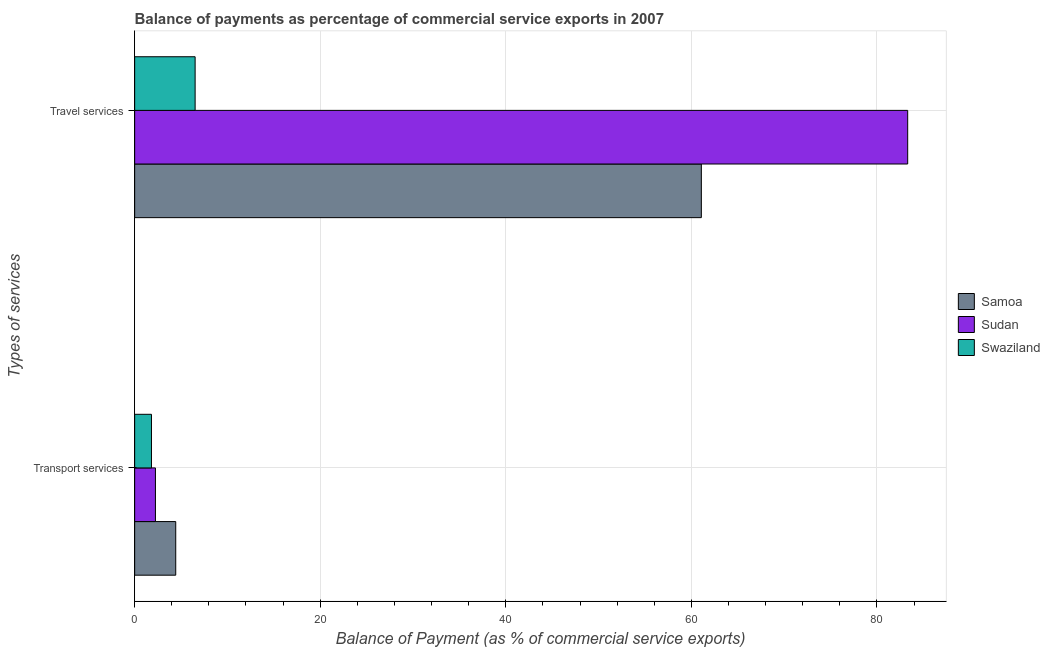How many groups of bars are there?
Your answer should be very brief. 2. Are the number of bars per tick equal to the number of legend labels?
Your answer should be compact. Yes. How many bars are there on the 2nd tick from the bottom?
Offer a very short reply. 3. What is the label of the 1st group of bars from the top?
Your response must be concise. Travel services. What is the balance of payments of transport services in Sudan?
Provide a short and direct response. 2.24. Across all countries, what is the maximum balance of payments of travel services?
Offer a terse response. 83.32. Across all countries, what is the minimum balance of payments of transport services?
Provide a succinct answer. 1.81. In which country was the balance of payments of travel services maximum?
Provide a succinct answer. Sudan. In which country was the balance of payments of travel services minimum?
Offer a very short reply. Swaziland. What is the total balance of payments of travel services in the graph?
Give a very brief answer. 150.92. What is the difference between the balance of payments of travel services in Sudan and that in Swaziland?
Your answer should be compact. 76.8. What is the difference between the balance of payments of transport services in Sudan and the balance of payments of travel services in Swaziland?
Offer a very short reply. -4.28. What is the average balance of payments of travel services per country?
Ensure brevity in your answer.  50.31. What is the difference between the balance of payments of transport services and balance of payments of travel services in Swaziland?
Ensure brevity in your answer.  -4.7. In how many countries, is the balance of payments of transport services greater than 76 %?
Offer a very short reply. 0. What is the ratio of the balance of payments of transport services in Swaziland to that in Sudan?
Make the answer very short. 0.81. Is the balance of payments of travel services in Sudan less than that in Samoa?
Your answer should be very brief. No. In how many countries, is the balance of payments of travel services greater than the average balance of payments of travel services taken over all countries?
Provide a short and direct response. 2. What does the 1st bar from the top in Travel services represents?
Your response must be concise. Swaziland. What does the 2nd bar from the bottom in Travel services represents?
Give a very brief answer. Sudan. How many bars are there?
Provide a succinct answer. 6. How many countries are there in the graph?
Ensure brevity in your answer.  3. What is the difference between two consecutive major ticks on the X-axis?
Your answer should be very brief. 20. Are the values on the major ticks of X-axis written in scientific E-notation?
Ensure brevity in your answer.  No. Where does the legend appear in the graph?
Offer a very short reply. Center right. How many legend labels are there?
Ensure brevity in your answer.  3. What is the title of the graph?
Provide a succinct answer. Balance of payments as percentage of commercial service exports in 2007. Does "Netherlands" appear as one of the legend labels in the graph?
Offer a terse response. No. What is the label or title of the X-axis?
Ensure brevity in your answer.  Balance of Payment (as % of commercial service exports). What is the label or title of the Y-axis?
Your answer should be very brief. Types of services. What is the Balance of Payment (as % of commercial service exports) of Samoa in Transport services?
Offer a terse response. 4.43. What is the Balance of Payment (as % of commercial service exports) of Sudan in Transport services?
Offer a very short reply. 2.24. What is the Balance of Payment (as % of commercial service exports) in Swaziland in Transport services?
Your answer should be very brief. 1.81. What is the Balance of Payment (as % of commercial service exports) in Samoa in Travel services?
Offer a terse response. 61.08. What is the Balance of Payment (as % of commercial service exports) of Sudan in Travel services?
Provide a short and direct response. 83.32. What is the Balance of Payment (as % of commercial service exports) in Swaziland in Travel services?
Give a very brief answer. 6.52. Across all Types of services, what is the maximum Balance of Payment (as % of commercial service exports) in Samoa?
Make the answer very short. 61.08. Across all Types of services, what is the maximum Balance of Payment (as % of commercial service exports) in Sudan?
Keep it short and to the point. 83.32. Across all Types of services, what is the maximum Balance of Payment (as % of commercial service exports) of Swaziland?
Ensure brevity in your answer.  6.52. Across all Types of services, what is the minimum Balance of Payment (as % of commercial service exports) of Samoa?
Provide a short and direct response. 4.43. Across all Types of services, what is the minimum Balance of Payment (as % of commercial service exports) in Sudan?
Offer a very short reply. 2.24. Across all Types of services, what is the minimum Balance of Payment (as % of commercial service exports) of Swaziland?
Offer a very short reply. 1.81. What is the total Balance of Payment (as % of commercial service exports) of Samoa in the graph?
Provide a short and direct response. 65.51. What is the total Balance of Payment (as % of commercial service exports) in Sudan in the graph?
Give a very brief answer. 85.56. What is the total Balance of Payment (as % of commercial service exports) in Swaziland in the graph?
Your answer should be compact. 8.33. What is the difference between the Balance of Payment (as % of commercial service exports) in Samoa in Transport services and that in Travel services?
Your answer should be compact. -56.65. What is the difference between the Balance of Payment (as % of commercial service exports) in Sudan in Transport services and that in Travel services?
Your response must be concise. -81.08. What is the difference between the Balance of Payment (as % of commercial service exports) of Swaziland in Transport services and that in Travel services?
Your response must be concise. -4.7. What is the difference between the Balance of Payment (as % of commercial service exports) of Samoa in Transport services and the Balance of Payment (as % of commercial service exports) of Sudan in Travel services?
Your answer should be very brief. -78.89. What is the difference between the Balance of Payment (as % of commercial service exports) in Samoa in Transport services and the Balance of Payment (as % of commercial service exports) in Swaziland in Travel services?
Your response must be concise. -2.09. What is the difference between the Balance of Payment (as % of commercial service exports) in Sudan in Transport services and the Balance of Payment (as % of commercial service exports) in Swaziland in Travel services?
Ensure brevity in your answer.  -4.28. What is the average Balance of Payment (as % of commercial service exports) of Samoa per Types of services?
Keep it short and to the point. 32.75. What is the average Balance of Payment (as % of commercial service exports) in Sudan per Types of services?
Provide a short and direct response. 42.78. What is the average Balance of Payment (as % of commercial service exports) in Swaziland per Types of services?
Your response must be concise. 4.17. What is the difference between the Balance of Payment (as % of commercial service exports) of Samoa and Balance of Payment (as % of commercial service exports) of Sudan in Transport services?
Provide a short and direct response. 2.19. What is the difference between the Balance of Payment (as % of commercial service exports) in Samoa and Balance of Payment (as % of commercial service exports) in Swaziland in Transport services?
Make the answer very short. 2.62. What is the difference between the Balance of Payment (as % of commercial service exports) of Sudan and Balance of Payment (as % of commercial service exports) of Swaziland in Transport services?
Provide a short and direct response. 0.43. What is the difference between the Balance of Payment (as % of commercial service exports) in Samoa and Balance of Payment (as % of commercial service exports) in Sudan in Travel services?
Ensure brevity in your answer.  -22.24. What is the difference between the Balance of Payment (as % of commercial service exports) of Samoa and Balance of Payment (as % of commercial service exports) of Swaziland in Travel services?
Your answer should be compact. 54.56. What is the difference between the Balance of Payment (as % of commercial service exports) of Sudan and Balance of Payment (as % of commercial service exports) of Swaziland in Travel services?
Your answer should be very brief. 76.8. What is the ratio of the Balance of Payment (as % of commercial service exports) of Samoa in Transport services to that in Travel services?
Your answer should be very brief. 0.07. What is the ratio of the Balance of Payment (as % of commercial service exports) in Sudan in Transport services to that in Travel services?
Offer a terse response. 0.03. What is the ratio of the Balance of Payment (as % of commercial service exports) in Swaziland in Transport services to that in Travel services?
Your answer should be compact. 0.28. What is the difference between the highest and the second highest Balance of Payment (as % of commercial service exports) in Samoa?
Provide a succinct answer. 56.65. What is the difference between the highest and the second highest Balance of Payment (as % of commercial service exports) in Sudan?
Make the answer very short. 81.08. What is the difference between the highest and the second highest Balance of Payment (as % of commercial service exports) in Swaziland?
Your response must be concise. 4.7. What is the difference between the highest and the lowest Balance of Payment (as % of commercial service exports) in Samoa?
Provide a short and direct response. 56.65. What is the difference between the highest and the lowest Balance of Payment (as % of commercial service exports) in Sudan?
Provide a succinct answer. 81.08. What is the difference between the highest and the lowest Balance of Payment (as % of commercial service exports) of Swaziland?
Offer a very short reply. 4.7. 